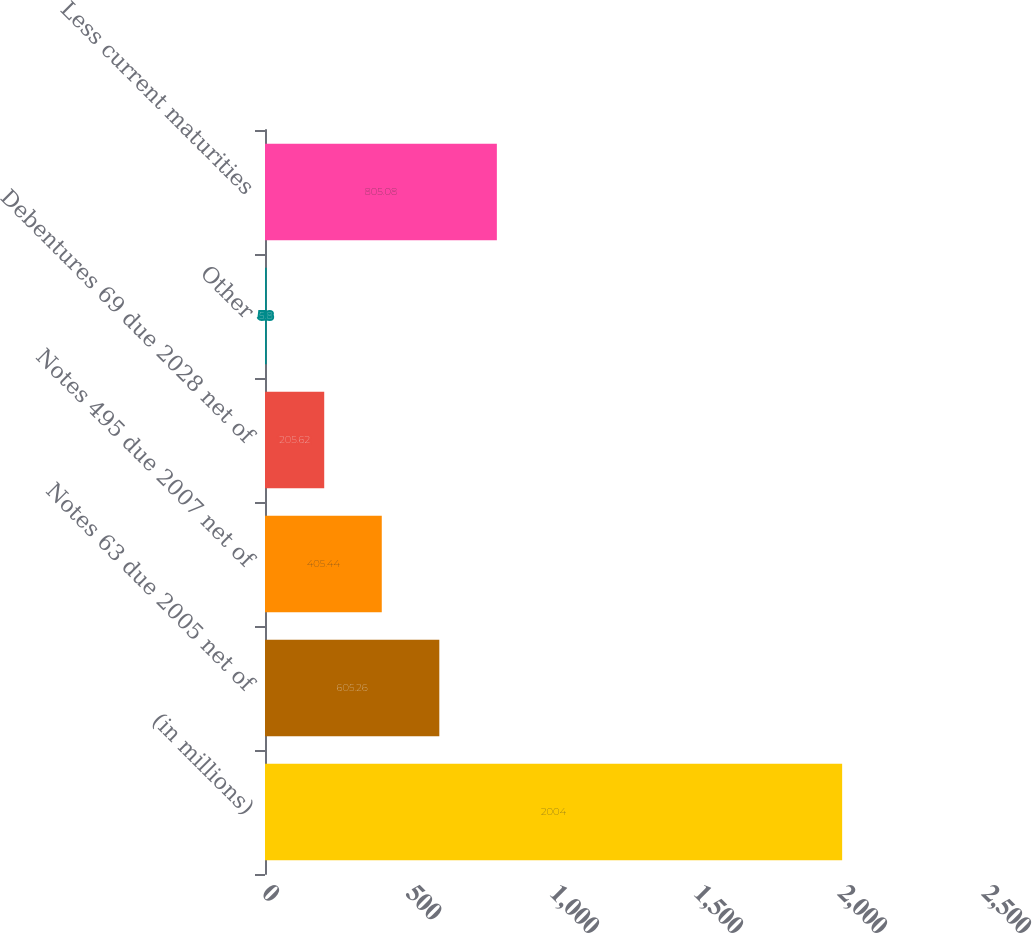Convert chart. <chart><loc_0><loc_0><loc_500><loc_500><bar_chart><fcel>(in millions)<fcel>Notes 63 due 2005 net of<fcel>Notes 495 due 2007 net of<fcel>Debentures 69 due 2028 net of<fcel>Other<fcel>Less current maturities<nl><fcel>2004<fcel>605.26<fcel>405.44<fcel>205.62<fcel>5.8<fcel>805.08<nl></chart> 